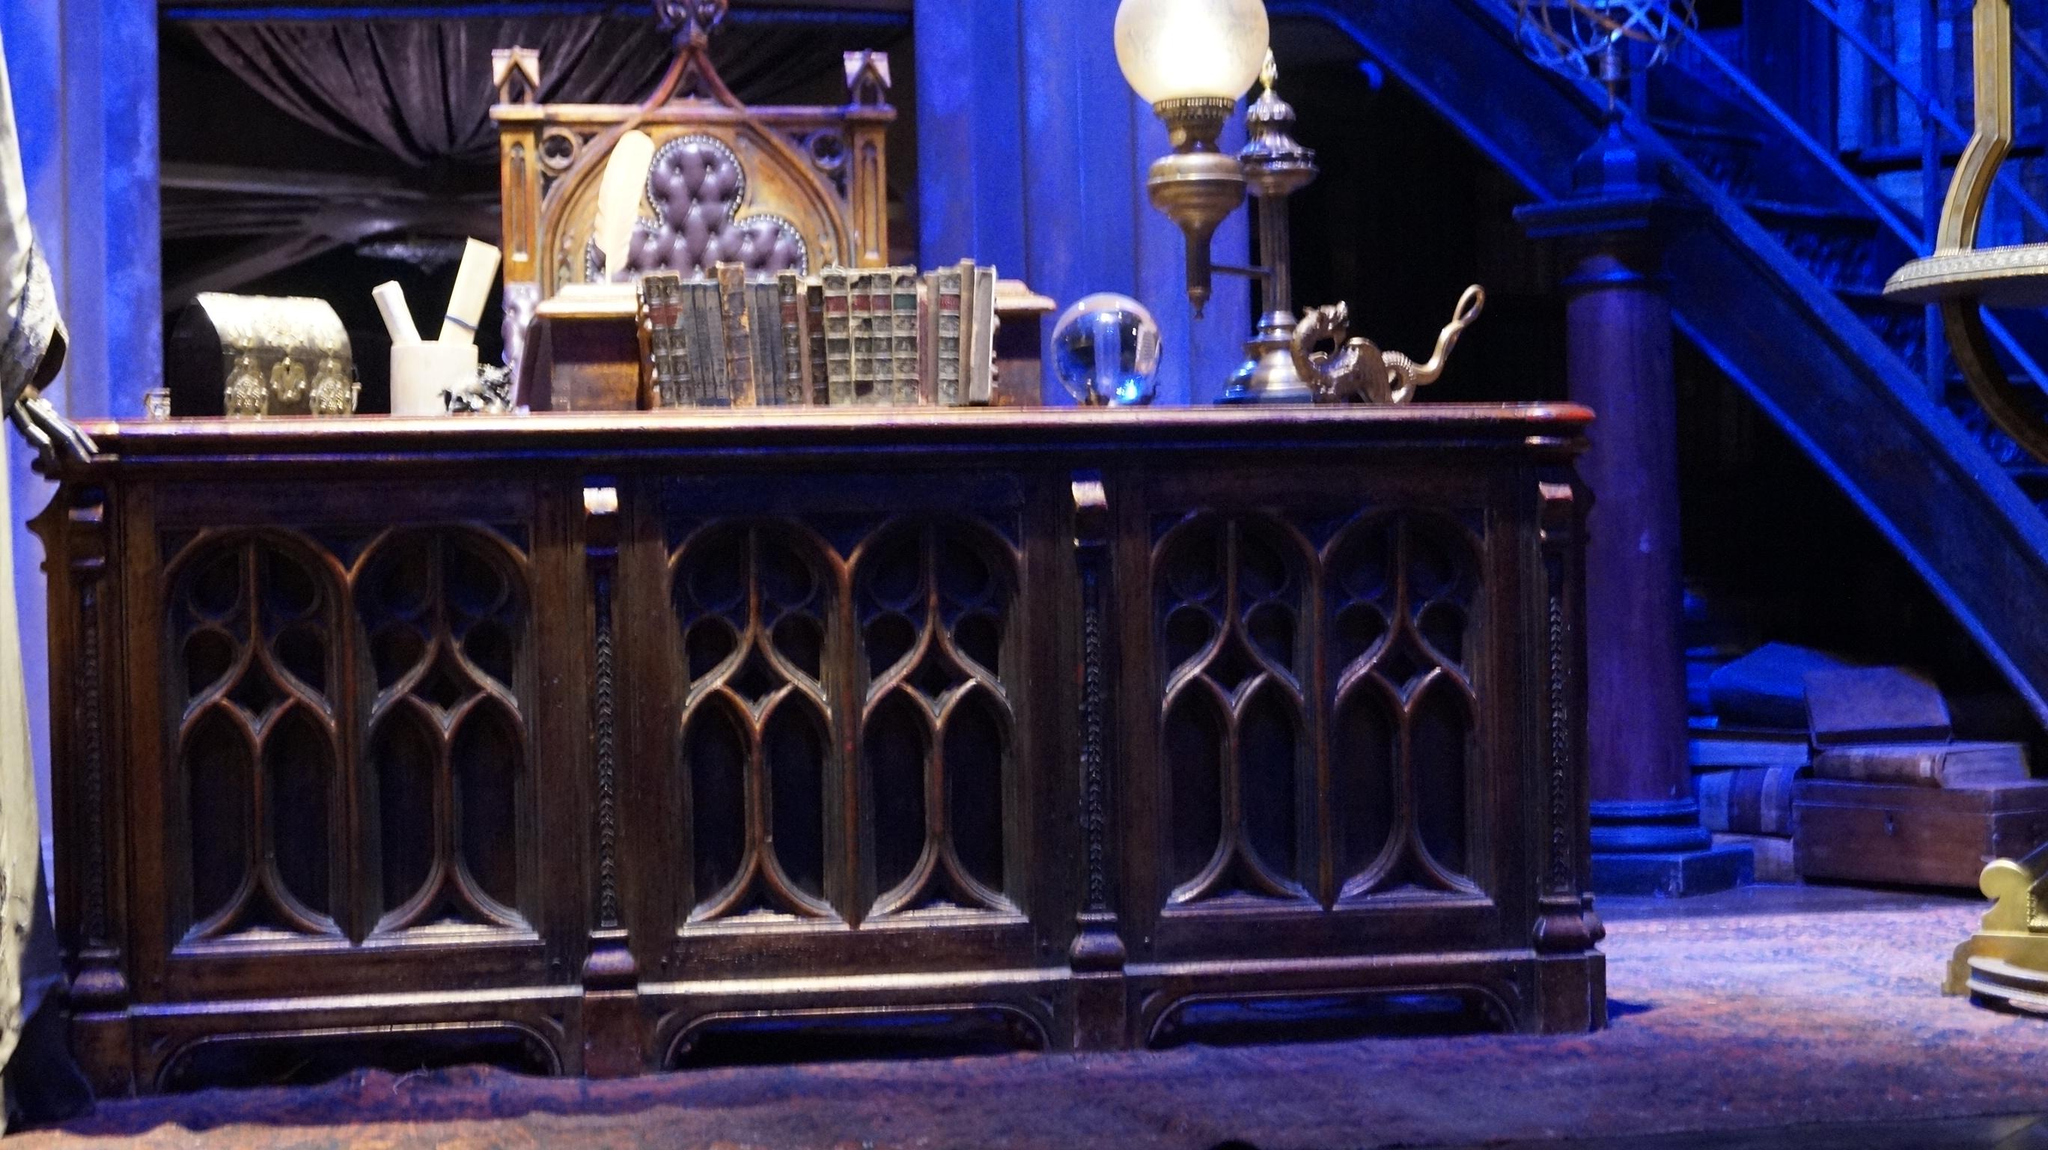What piece of furniture is present in the image? There is a table in the image. What is on top of the table? There are objects on the table. What source of illumination is visible in the image? There is a light in the image. What architectural feature can be seen in the image? There is a pillar in the image. Where is the cattle nest located in the image? There is no cattle or nest present in the image. What type of play is happening in the image? There is no play or indication of any activity happening in the image. 